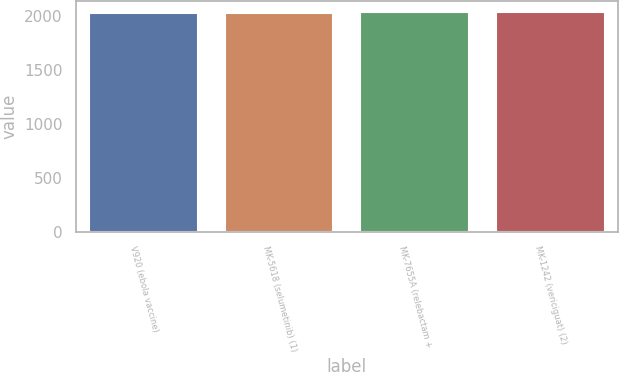Convert chart to OTSL. <chart><loc_0><loc_0><loc_500><loc_500><bar_chart><fcel>V920 (ebola vaccine)<fcel>MK-5618 (selumetinib) (1)<fcel>MK-7655A (relebactam +<fcel>MK-1242 (vericiguat) (2)<nl><fcel>2023<fcel>2023.8<fcel>2030<fcel>2031<nl></chart> 